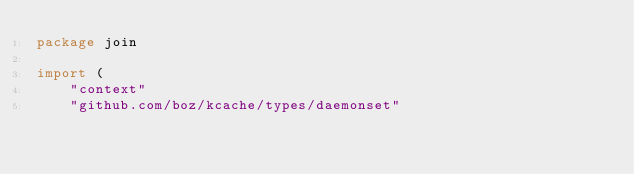<code> <loc_0><loc_0><loc_500><loc_500><_Go_>package join

import (
	"context"
	"github.com/boz/kcache/types/daemonset"</code> 